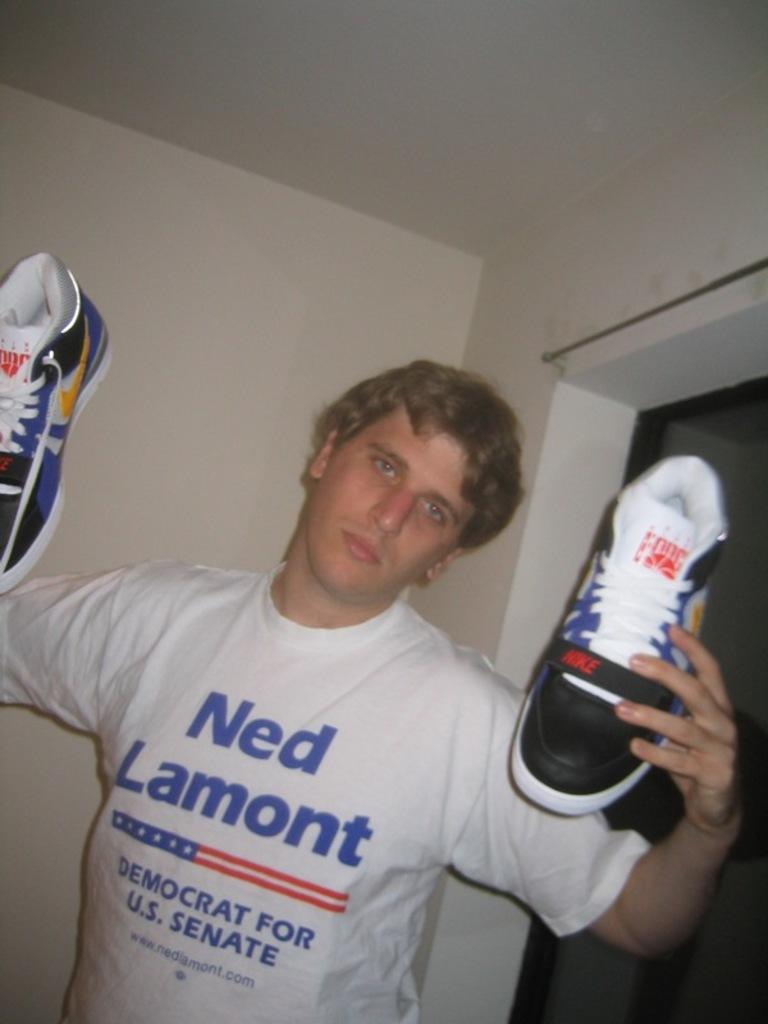<image>
Render a clear and concise summary of the photo. Man wearing a white shirt that says Ned Lamont on it. 